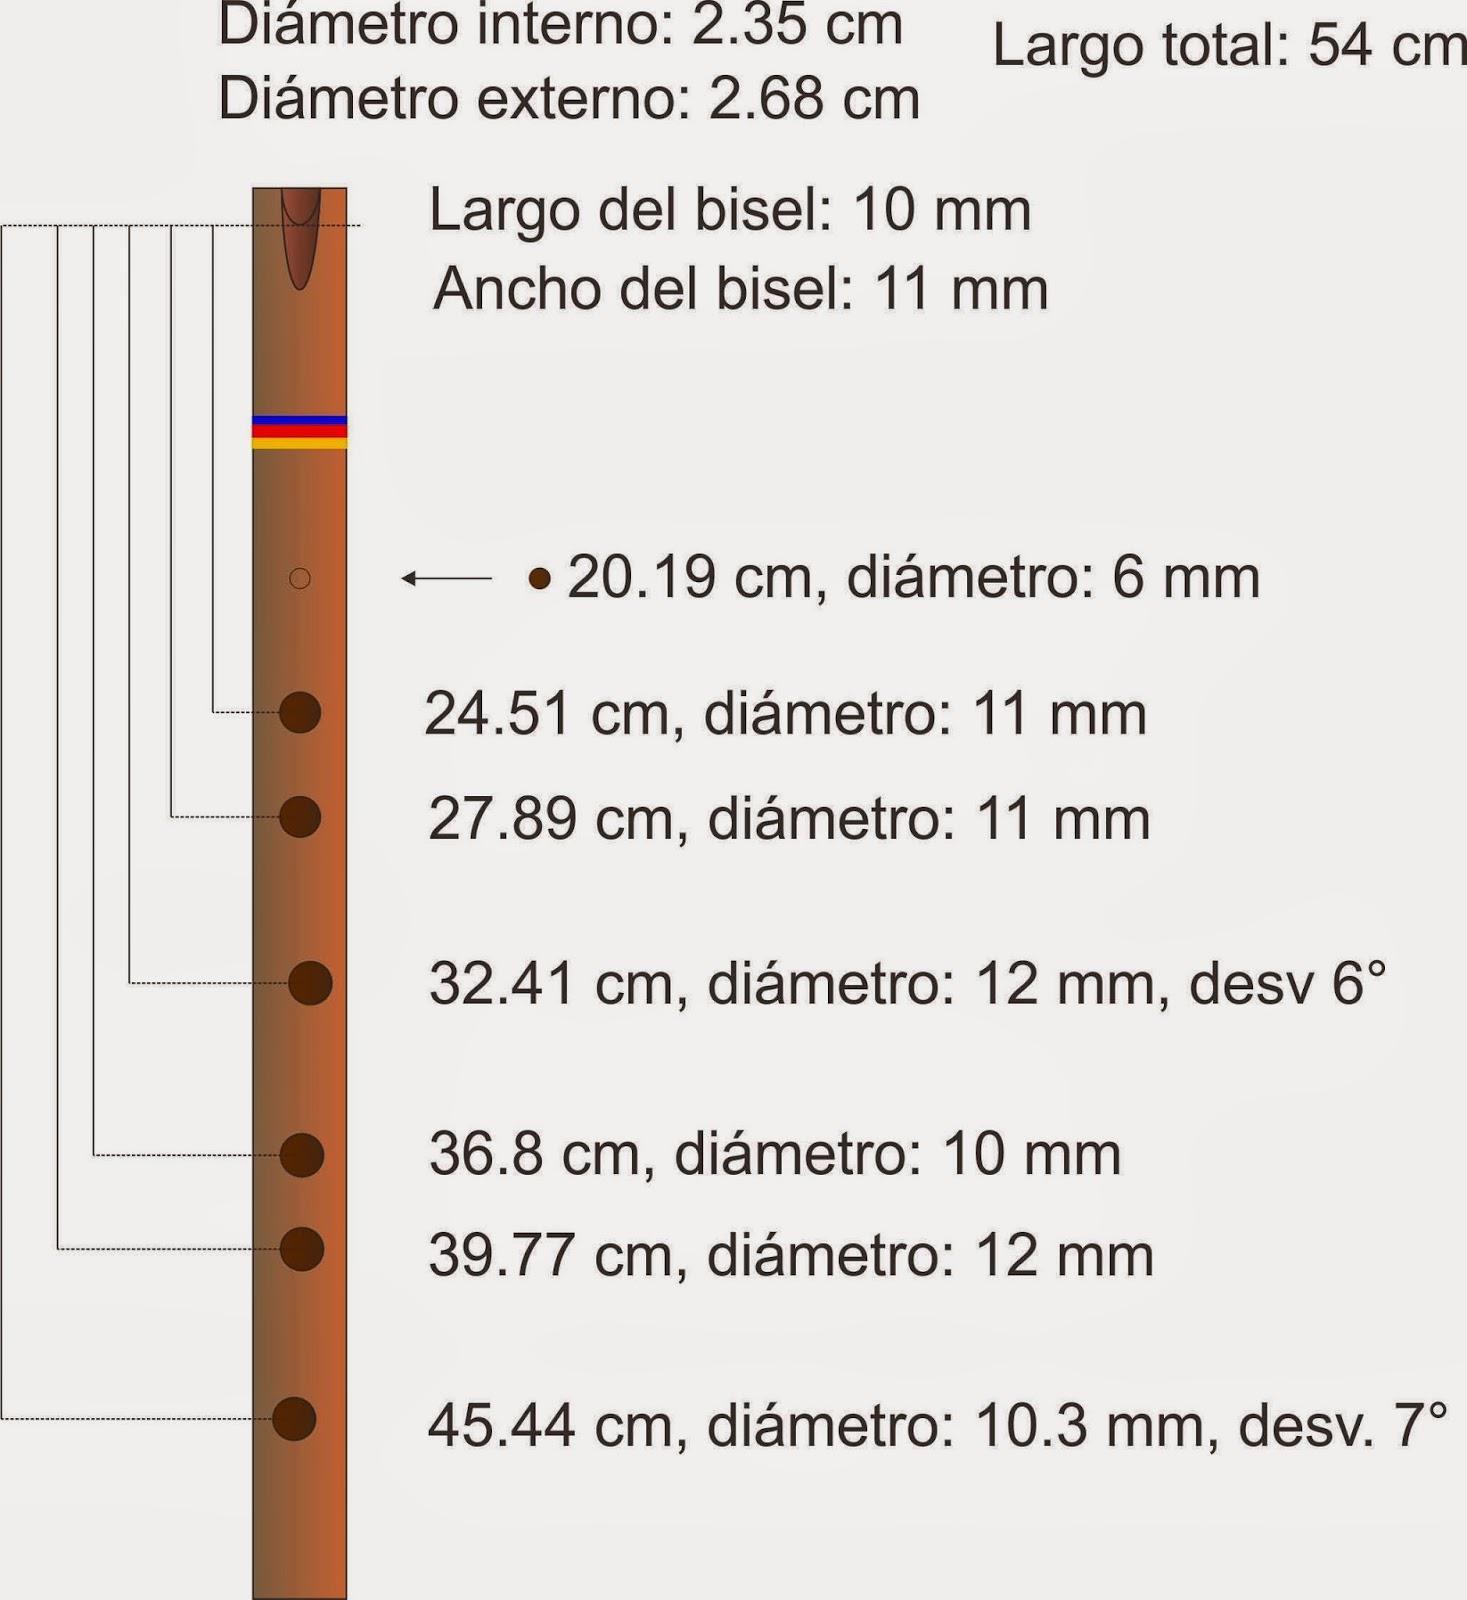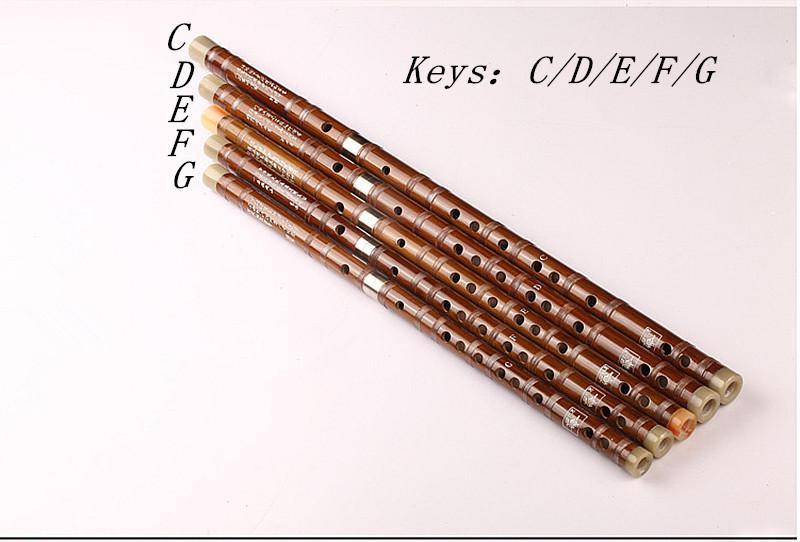The first image is the image on the left, the second image is the image on the right. Evaluate the accuracy of this statement regarding the images: "Each image features one bamboo flute displayed diagonally so one end is on the upper right.". Is it true? Answer yes or no. No. The first image is the image on the left, the second image is the image on the right. For the images shown, is this caption "There are exactly two flutes." true? Answer yes or no. No. 